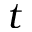<formula> <loc_0><loc_0><loc_500><loc_500>t</formula> 